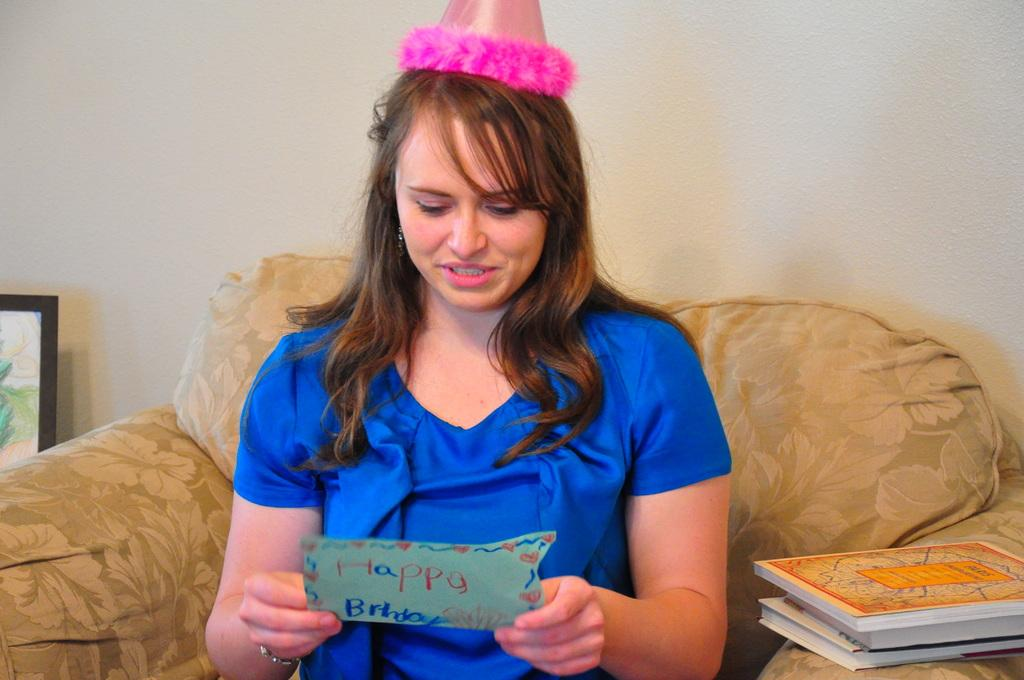Who is present in the image? There is a woman in the image. What is the woman doing in the image? The woman is sitting on a chair. What is the woman holding in the image? The woman is holding a card. What is the woman wearing in the image? The woman is wearing a cap. What else can be seen near the woman in the image? There are books beside the woman. What can be seen in the background of the image? There is a frame and a wall in the background of the image. What street is the woman laughing on in the image? There is no street present in the image, and the woman is not laughing. 